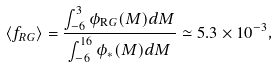<formula> <loc_0><loc_0><loc_500><loc_500>\langle f _ { R G } \rangle = \frac { \int _ { - 6 } ^ { 3 } \phi _ { \mathrm R G } ( M ) d M } { \int _ { - 6 } ^ { 1 6 } \phi _ { * } ( M ) d M } \simeq 5 . 3 \times 1 0 ^ { - 3 } ,</formula> 